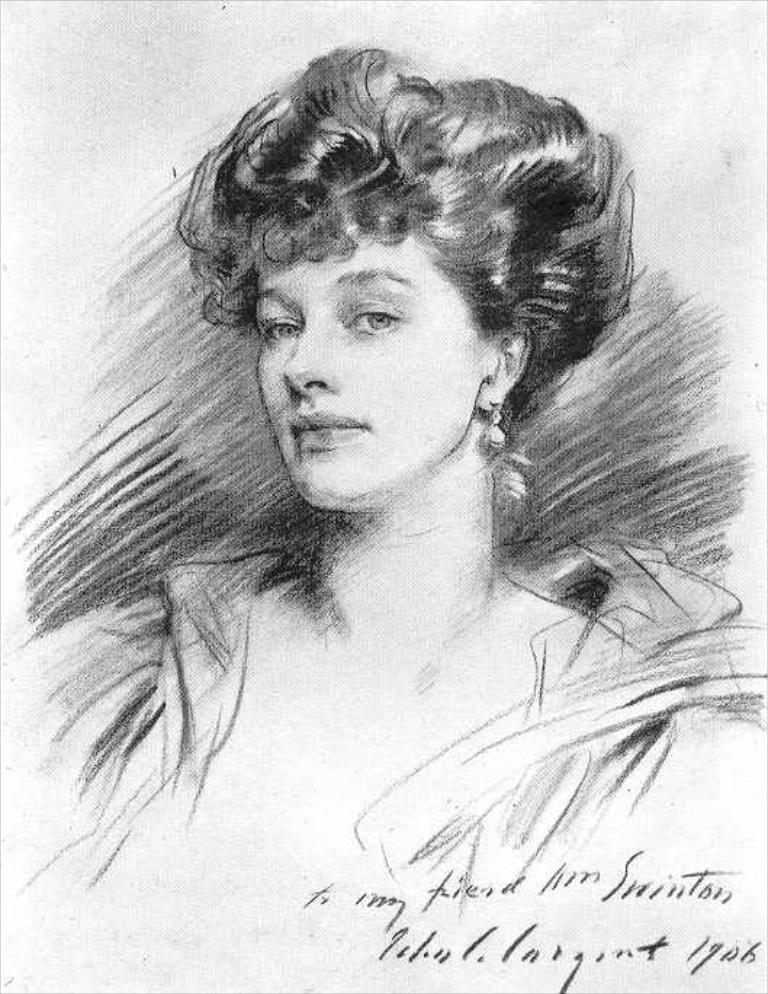What type of artwork is depicted in the image? There is a pencil sketch of a woman in the image. Can you describe the subject of the sketch? The subject of the sketch is a woman. How many dogs are present in the image? There are no dogs present in the image; it features a pencil sketch of a woman. 